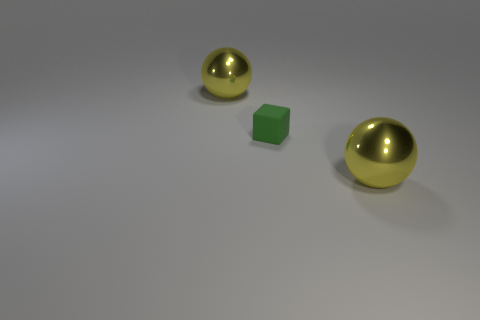Add 3 tiny green blocks. How many objects exist? 6 Subtract all spheres. How many objects are left? 1 Add 2 green objects. How many green objects exist? 3 Subtract 1 yellow balls. How many objects are left? 2 Subtract all big green matte cylinders. Subtract all tiny green rubber cubes. How many objects are left? 2 Add 1 large objects. How many large objects are left? 3 